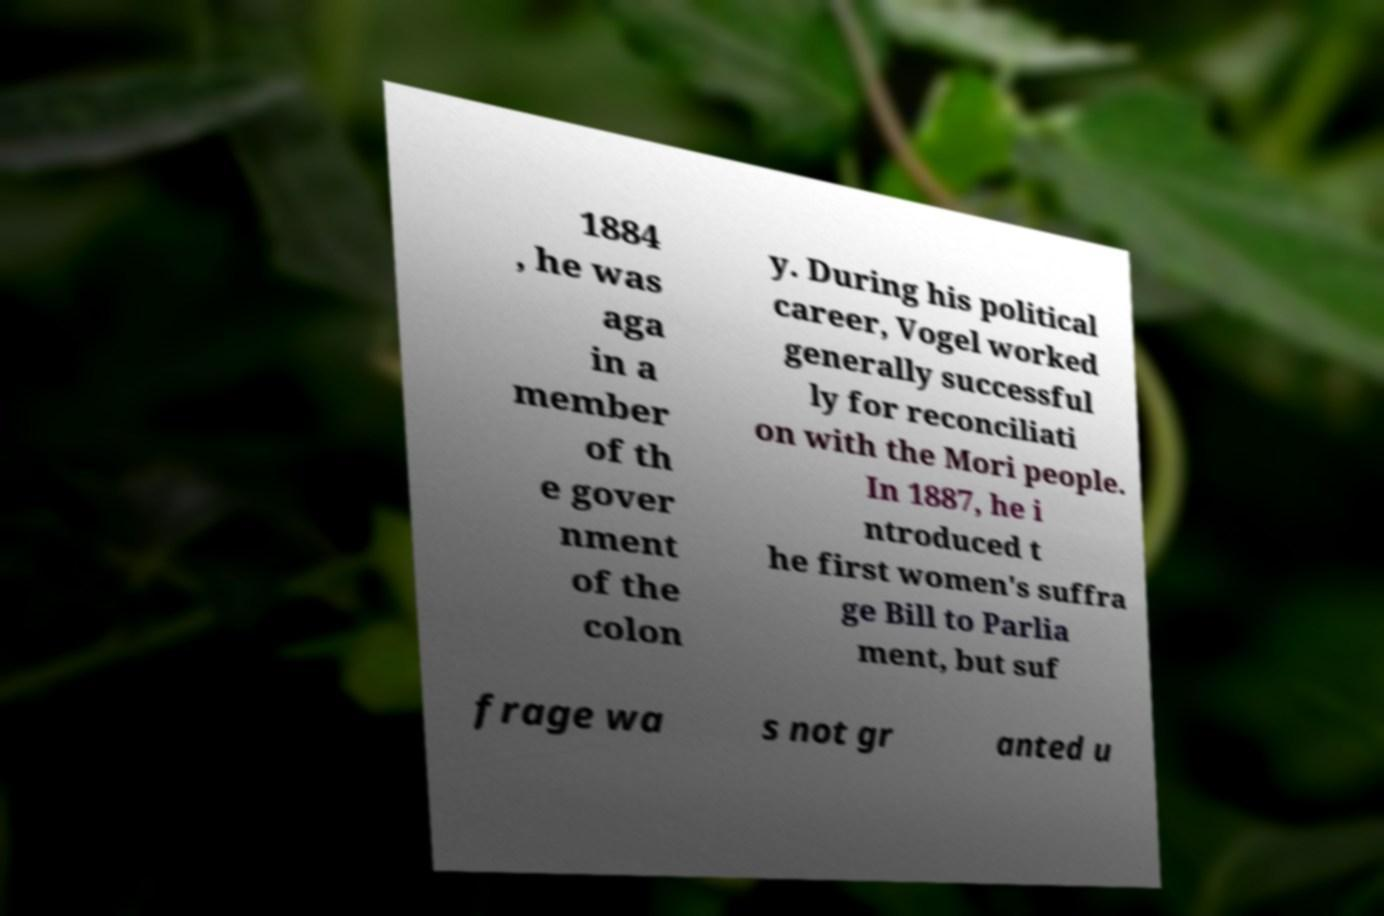There's text embedded in this image that I need extracted. Can you transcribe it verbatim? 1884 , he was aga in a member of th e gover nment of the colon y. During his political career, Vogel worked generally successful ly for reconciliati on with the Mori people. In 1887, he i ntroduced t he first women's suffra ge Bill to Parlia ment, but suf frage wa s not gr anted u 